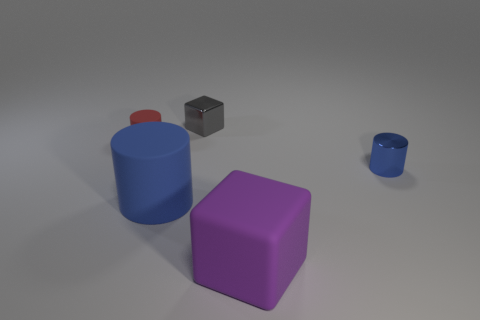Subtract all large cylinders. How many cylinders are left? 2 Subtract all gray cubes. How many blue cylinders are left? 2 Add 2 purple things. How many objects exist? 7 Subtract 1 cylinders. How many cylinders are left? 2 Subtract all purple cylinders. Subtract all yellow spheres. How many cylinders are left? 3 Subtract 0 red spheres. How many objects are left? 5 Subtract all cylinders. How many objects are left? 2 Subtract all matte cylinders. Subtract all small cylinders. How many objects are left? 1 Add 5 tiny blue metallic cylinders. How many tiny blue metallic cylinders are left? 6 Add 5 tiny purple matte cylinders. How many tiny purple matte cylinders exist? 5 